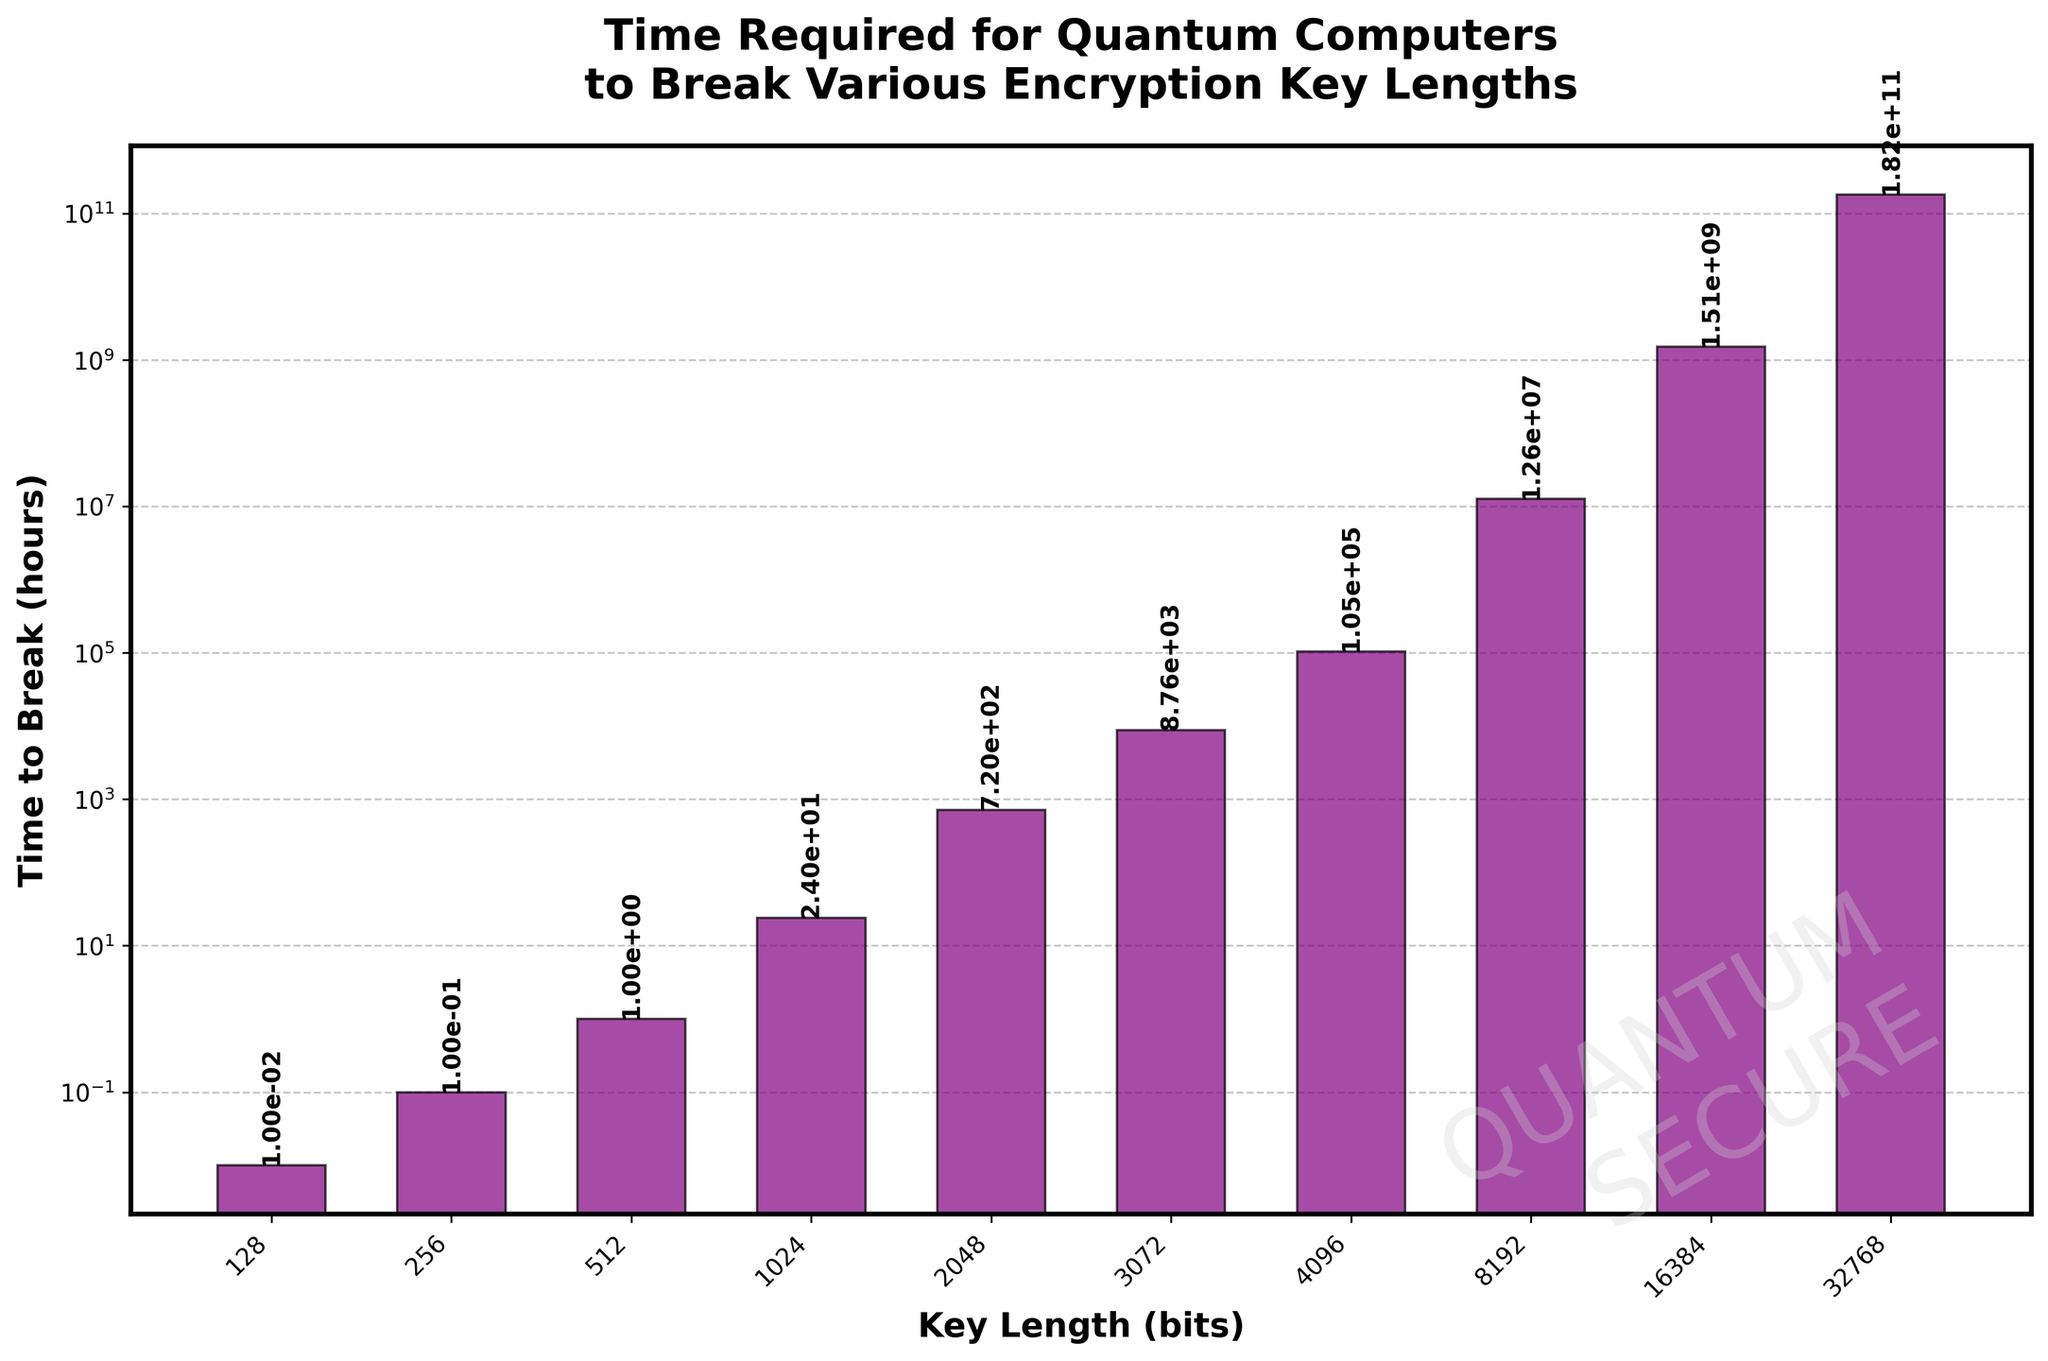What is the shortest time required to break an encryption key length, as shown in the figure? The shortest bar represents the shortest time to break an encryption key length. According to the y-axis and the label on the shortest bar, the time required is 0.01 hours for the 128-bit key.
Answer: 0.01 hours How many times longer does it take to break a 256-bit key compared to a 128-bit key? To find the ratio, divide the time to break the 256-bit key by the time to break the 128-bit key. That is, 0.1 hours / 0.01 hours.
Answer: 10 times Which encryption key length requires approximately one year to break? According to the figure, one year is about 8760 hours. Find the key length corresponding to the bar height closest to 8760 hours, which is the 3072-bit key length.
Answer: 3072 bits By how much does the time to break a 4096-bit key exceed the time to break a 2048-bit key? Subtract the time to break the 2048-bit key from the time to break the 4096-bit key: 105120 hours - 720 hours.
Answer: 104400 hours Which encryption key length's breaking time is labeled as 1.51e+09 hours? Observe the y-axis labels and locate the bar with the corresponding label (1.51e+09 hours is labeled on the bar for the 16384-bit key length).
Answer: 16384 bits Compare the time to break a 1024-bit key with a 512-bit key. Which one takes longer, and by how much? Find the bars for 512-bit and 1024-bit keys and subtract the smaller time from the larger. It's 24 hours for 1024-bit and 1 hour for 512-bit, resulting in 24 - 1.
Answer: 1024-bit, 23 hours longer What is the approximate visual difference in bar heights between 8192-bit and 16384-bit keys? It's challenging to calculate precisely from the visual aspect, but observe that the height difference is considerable yet not qualitative due to the logarithmic scale. Both labels show the rapid increase from 12614400 to 1513728000 hours.
Answer: Large, by over a billion hours Which key length has a breaking time labeled with a scientific notation of 1.82e+11 hours? The only bar with that label corresponds to the 32768-bit key length, as visualized by the highest bar.
Answer: 32768 bits 